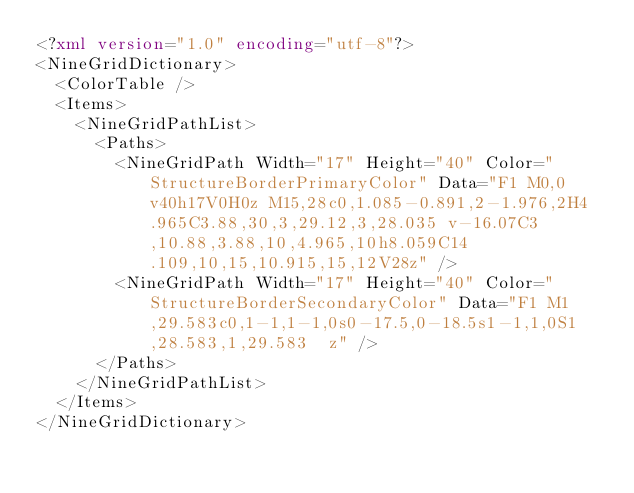Convert code to text. <code><loc_0><loc_0><loc_500><loc_500><_XML_><?xml version="1.0" encoding="utf-8"?>
<NineGridDictionary>
  <ColorTable />
  <Items>
    <NineGridPathList>
      <Paths>
        <NineGridPath Width="17" Height="40" Color="StructureBorderPrimaryColor" Data="F1 M0,0v40h17V0H0z M15,28c0,1.085-0.891,2-1.976,2H4.965C3.88,30,3,29.12,3,28.035 v-16.07C3,10.88,3.88,10,4.965,10h8.059C14.109,10,15,10.915,15,12V28z" />
        <NineGridPath Width="17" Height="40" Color="StructureBorderSecondaryColor" Data="F1 M1,29.583c0,1-1,1-1,0s0-17.5,0-18.5s1-1,1,0S1,28.583,1,29.583  z" />
      </Paths>
    </NineGridPathList>
  </Items>
</NineGridDictionary></code> 